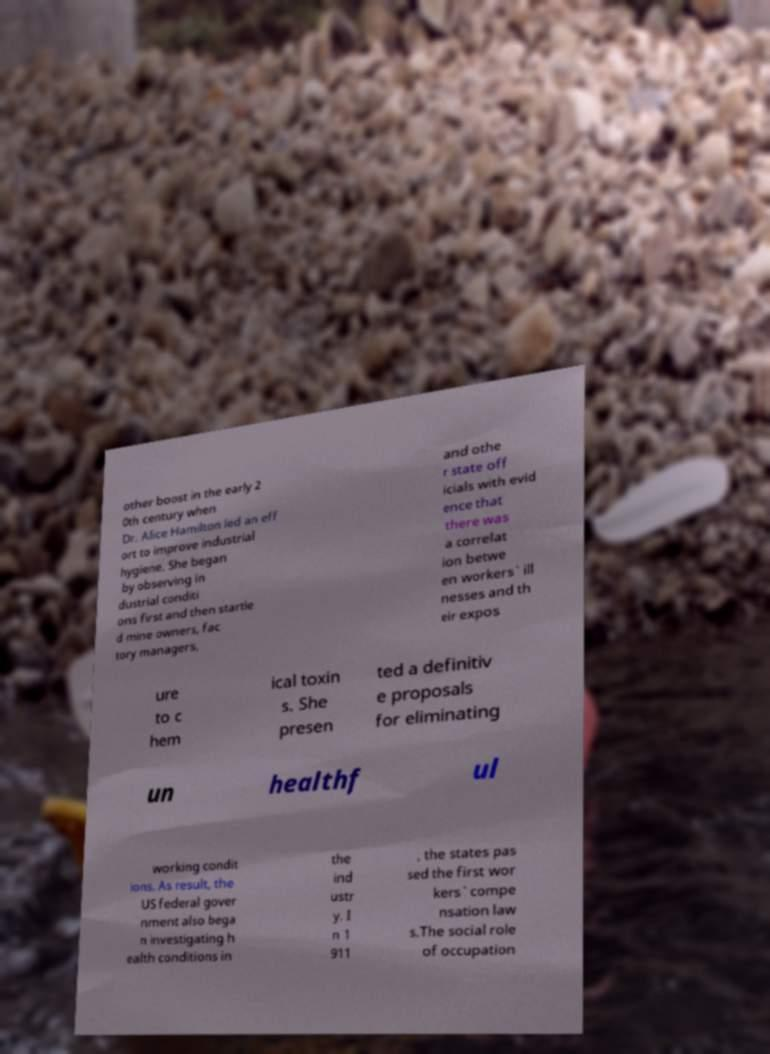Please identify and transcribe the text found in this image. other boost in the early 2 0th century when Dr. Alice Hamilton led an eff ort to improve industrial hygiene. She began by observing in dustrial conditi ons first and then startle d mine owners, fac tory managers, and othe r state off icials with evid ence that there was a correlat ion betwe en workers` ill nesses and th eir expos ure to c hem ical toxin s. She presen ted a definitiv e proposals for eliminating un healthf ul working condit ions. As result, the US federal gover nment also bega n investigating h ealth conditions in the ind ustr y. I n 1 911 , the states pas sed the first wor kers` compe nsation law s.The social role of occupation 